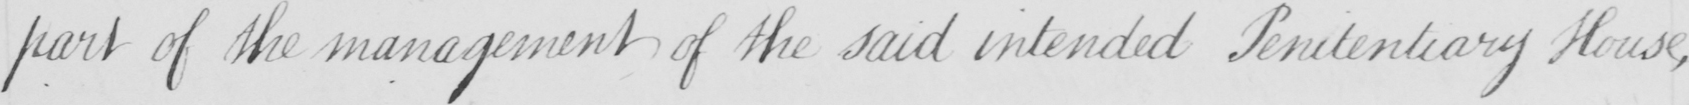What does this handwritten line say? part of the management of the said intended Penitentiary House , 